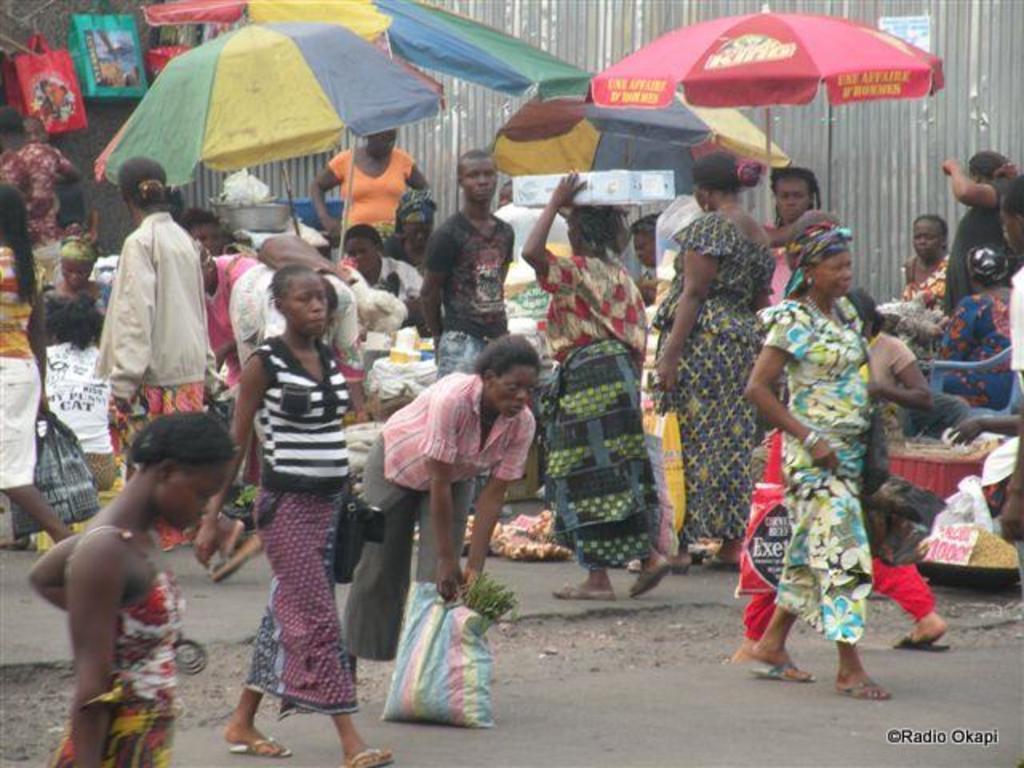Please provide a concise description of this image. In this image we can see persons on road, vegetables, umbrellas, bags and wall. 